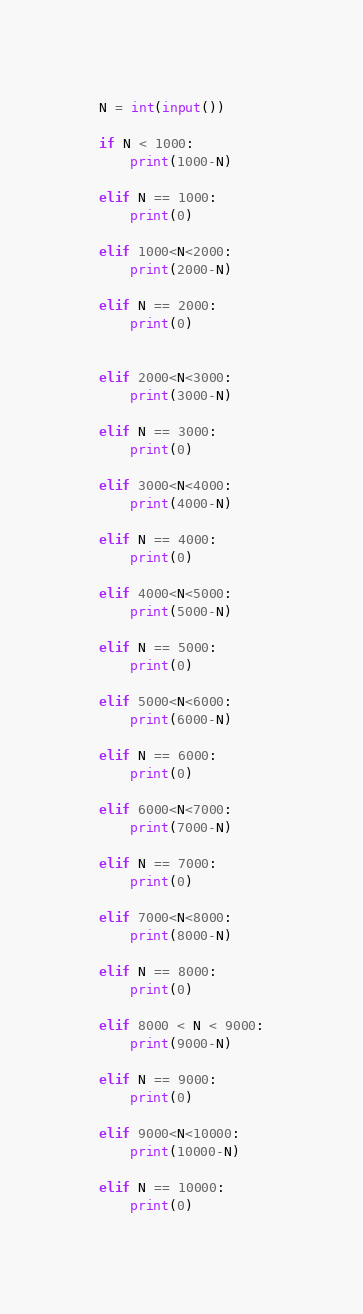Convert code to text. <code><loc_0><loc_0><loc_500><loc_500><_Python_>N = int(input())

if N < 1000:
    print(1000-N)

elif N == 1000:
    print(0)

elif 1000<N<2000:
    print(2000-N)

elif N == 2000:
    print(0)


elif 2000<N<3000:
    print(3000-N)

elif N == 3000:
    print(0)

elif 3000<N<4000:
    print(4000-N)

elif N == 4000:
    print(0)

elif 4000<N<5000:
    print(5000-N)

elif N == 5000:
    print(0)

elif 5000<N<6000:
    print(6000-N)

elif N == 6000:
    print(0)

elif 6000<N<7000:
    print(7000-N)

elif N == 7000:
    print(0)

elif 7000<N<8000:
    print(8000-N)

elif N == 8000:
    print(0)

elif 8000 < N < 9000:
    print(9000-N)

elif N == 9000:
    print(0)

elif 9000<N<10000:
    print(10000-N)

elif N == 10000:
    print(0)</code> 